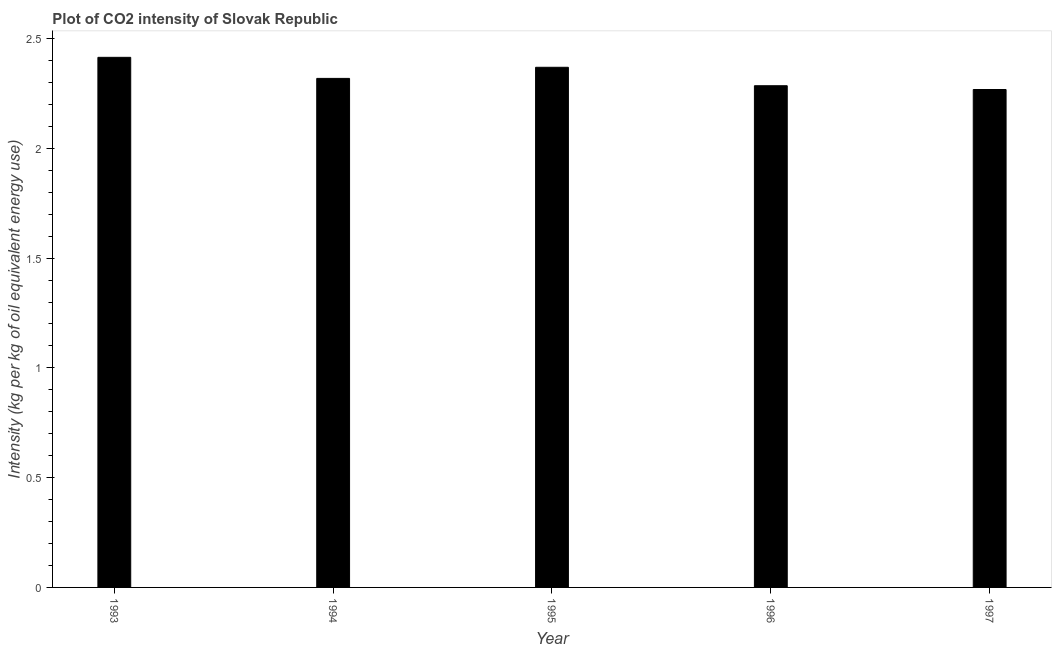Does the graph contain any zero values?
Make the answer very short. No. What is the title of the graph?
Give a very brief answer. Plot of CO2 intensity of Slovak Republic. What is the label or title of the X-axis?
Ensure brevity in your answer.  Year. What is the label or title of the Y-axis?
Keep it short and to the point. Intensity (kg per kg of oil equivalent energy use). What is the co2 intensity in 1993?
Offer a terse response. 2.41. Across all years, what is the maximum co2 intensity?
Give a very brief answer. 2.41. Across all years, what is the minimum co2 intensity?
Offer a very short reply. 2.27. In which year was the co2 intensity maximum?
Your answer should be compact. 1993. What is the sum of the co2 intensity?
Provide a short and direct response. 11.66. What is the difference between the co2 intensity in 1993 and 1997?
Provide a succinct answer. 0.15. What is the average co2 intensity per year?
Offer a very short reply. 2.33. What is the median co2 intensity?
Give a very brief answer. 2.32. In how many years, is the co2 intensity greater than 0.8 kg?
Provide a short and direct response. 5. What is the ratio of the co2 intensity in 1993 to that in 1996?
Keep it short and to the point. 1.06. Is the co2 intensity in 1995 less than that in 1996?
Make the answer very short. No. What is the difference between the highest and the second highest co2 intensity?
Provide a short and direct response. 0.04. What is the difference between the highest and the lowest co2 intensity?
Ensure brevity in your answer.  0.15. How many bars are there?
Make the answer very short. 5. What is the Intensity (kg per kg of oil equivalent energy use) of 1993?
Ensure brevity in your answer.  2.41. What is the Intensity (kg per kg of oil equivalent energy use) in 1994?
Provide a short and direct response. 2.32. What is the Intensity (kg per kg of oil equivalent energy use) in 1995?
Provide a short and direct response. 2.37. What is the Intensity (kg per kg of oil equivalent energy use) in 1996?
Offer a very short reply. 2.29. What is the Intensity (kg per kg of oil equivalent energy use) in 1997?
Keep it short and to the point. 2.27. What is the difference between the Intensity (kg per kg of oil equivalent energy use) in 1993 and 1994?
Your response must be concise. 0.1. What is the difference between the Intensity (kg per kg of oil equivalent energy use) in 1993 and 1995?
Your answer should be compact. 0.05. What is the difference between the Intensity (kg per kg of oil equivalent energy use) in 1993 and 1996?
Offer a terse response. 0.13. What is the difference between the Intensity (kg per kg of oil equivalent energy use) in 1993 and 1997?
Your answer should be very brief. 0.15. What is the difference between the Intensity (kg per kg of oil equivalent energy use) in 1994 and 1995?
Make the answer very short. -0.05. What is the difference between the Intensity (kg per kg of oil equivalent energy use) in 1994 and 1996?
Offer a very short reply. 0.03. What is the difference between the Intensity (kg per kg of oil equivalent energy use) in 1994 and 1997?
Make the answer very short. 0.05. What is the difference between the Intensity (kg per kg of oil equivalent energy use) in 1995 and 1996?
Make the answer very short. 0.08. What is the difference between the Intensity (kg per kg of oil equivalent energy use) in 1995 and 1997?
Provide a succinct answer. 0.1. What is the difference between the Intensity (kg per kg of oil equivalent energy use) in 1996 and 1997?
Offer a very short reply. 0.02. What is the ratio of the Intensity (kg per kg of oil equivalent energy use) in 1993 to that in 1994?
Offer a terse response. 1.04. What is the ratio of the Intensity (kg per kg of oil equivalent energy use) in 1993 to that in 1995?
Your answer should be very brief. 1.02. What is the ratio of the Intensity (kg per kg of oil equivalent energy use) in 1993 to that in 1996?
Offer a terse response. 1.06. What is the ratio of the Intensity (kg per kg of oil equivalent energy use) in 1993 to that in 1997?
Make the answer very short. 1.06. What is the ratio of the Intensity (kg per kg of oil equivalent energy use) in 1994 to that in 1995?
Ensure brevity in your answer.  0.98. What is the ratio of the Intensity (kg per kg of oil equivalent energy use) in 1994 to that in 1996?
Make the answer very short. 1.01. What is the ratio of the Intensity (kg per kg of oil equivalent energy use) in 1995 to that in 1996?
Your answer should be compact. 1.04. What is the ratio of the Intensity (kg per kg of oil equivalent energy use) in 1995 to that in 1997?
Offer a terse response. 1.04. 